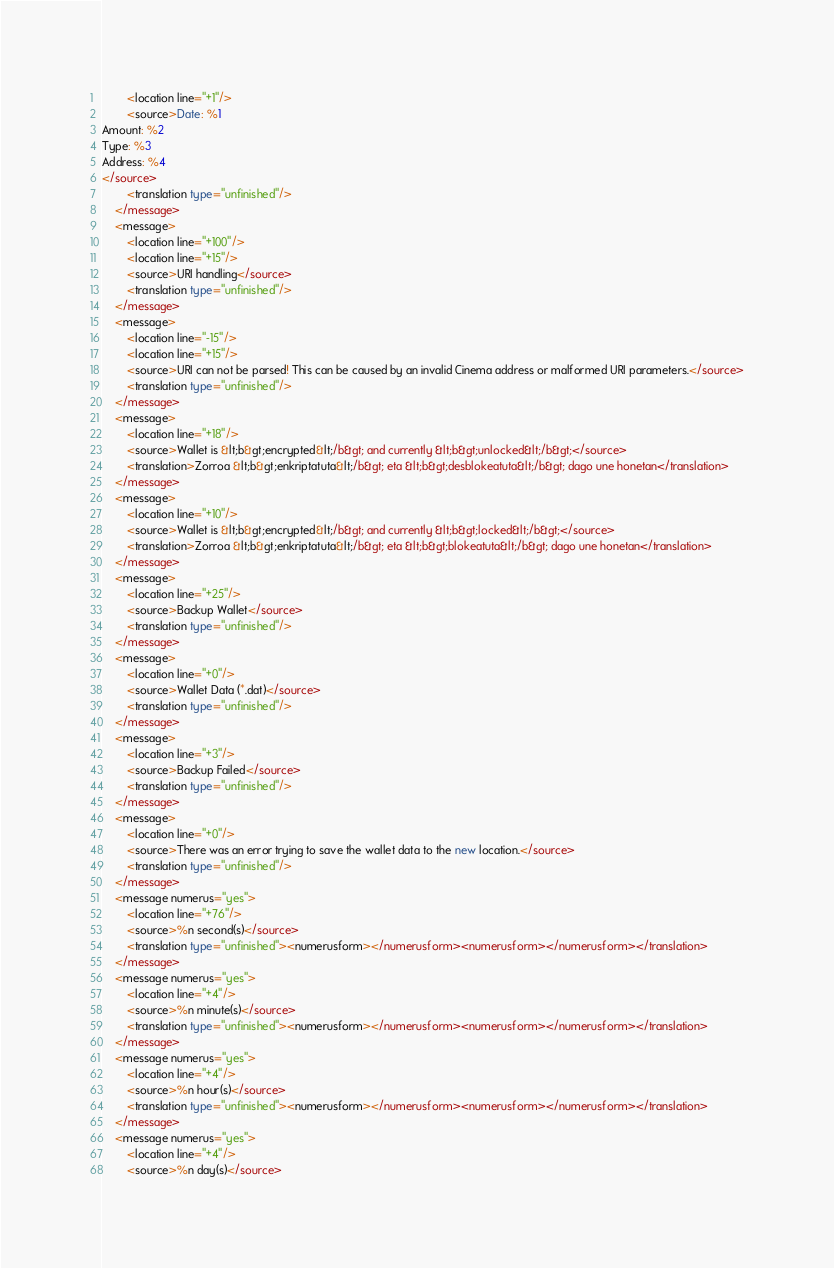<code> <loc_0><loc_0><loc_500><loc_500><_TypeScript_>        <location line="+1"/>
        <source>Date: %1
Amount: %2
Type: %3
Address: %4
</source>
        <translation type="unfinished"/>
    </message>
    <message>
        <location line="+100"/>
        <location line="+15"/>
        <source>URI handling</source>
        <translation type="unfinished"/>
    </message>
    <message>
        <location line="-15"/>
        <location line="+15"/>
        <source>URI can not be parsed! This can be caused by an invalid Cinema address or malformed URI parameters.</source>
        <translation type="unfinished"/>
    </message>
    <message>
        <location line="+18"/>
        <source>Wallet is &lt;b&gt;encrypted&lt;/b&gt; and currently &lt;b&gt;unlocked&lt;/b&gt;</source>
        <translation>Zorroa &lt;b&gt;enkriptatuta&lt;/b&gt; eta &lt;b&gt;desblokeatuta&lt;/b&gt; dago une honetan</translation>
    </message>
    <message>
        <location line="+10"/>
        <source>Wallet is &lt;b&gt;encrypted&lt;/b&gt; and currently &lt;b&gt;locked&lt;/b&gt;</source>
        <translation>Zorroa &lt;b&gt;enkriptatuta&lt;/b&gt; eta &lt;b&gt;blokeatuta&lt;/b&gt; dago une honetan</translation>
    </message>
    <message>
        <location line="+25"/>
        <source>Backup Wallet</source>
        <translation type="unfinished"/>
    </message>
    <message>
        <location line="+0"/>
        <source>Wallet Data (*.dat)</source>
        <translation type="unfinished"/>
    </message>
    <message>
        <location line="+3"/>
        <source>Backup Failed</source>
        <translation type="unfinished"/>
    </message>
    <message>
        <location line="+0"/>
        <source>There was an error trying to save the wallet data to the new location.</source>
        <translation type="unfinished"/>
    </message>
    <message numerus="yes">
        <location line="+76"/>
        <source>%n second(s)</source>
        <translation type="unfinished"><numerusform></numerusform><numerusform></numerusform></translation>
    </message>
    <message numerus="yes">
        <location line="+4"/>
        <source>%n minute(s)</source>
        <translation type="unfinished"><numerusform></numerusform><numerusform></numerusform></translation>
    </message>
    <message numerus="yes">
        <location line="+4"/>
        <source>%n hour(s)</source>
        <translation type="unfinished"><numerusform></numerusform><numerusform></numerusform></translation>
    </message>
    <message numerus="yes">
        <location line="+4"/>
        <source>%n day(s)</source></code> 